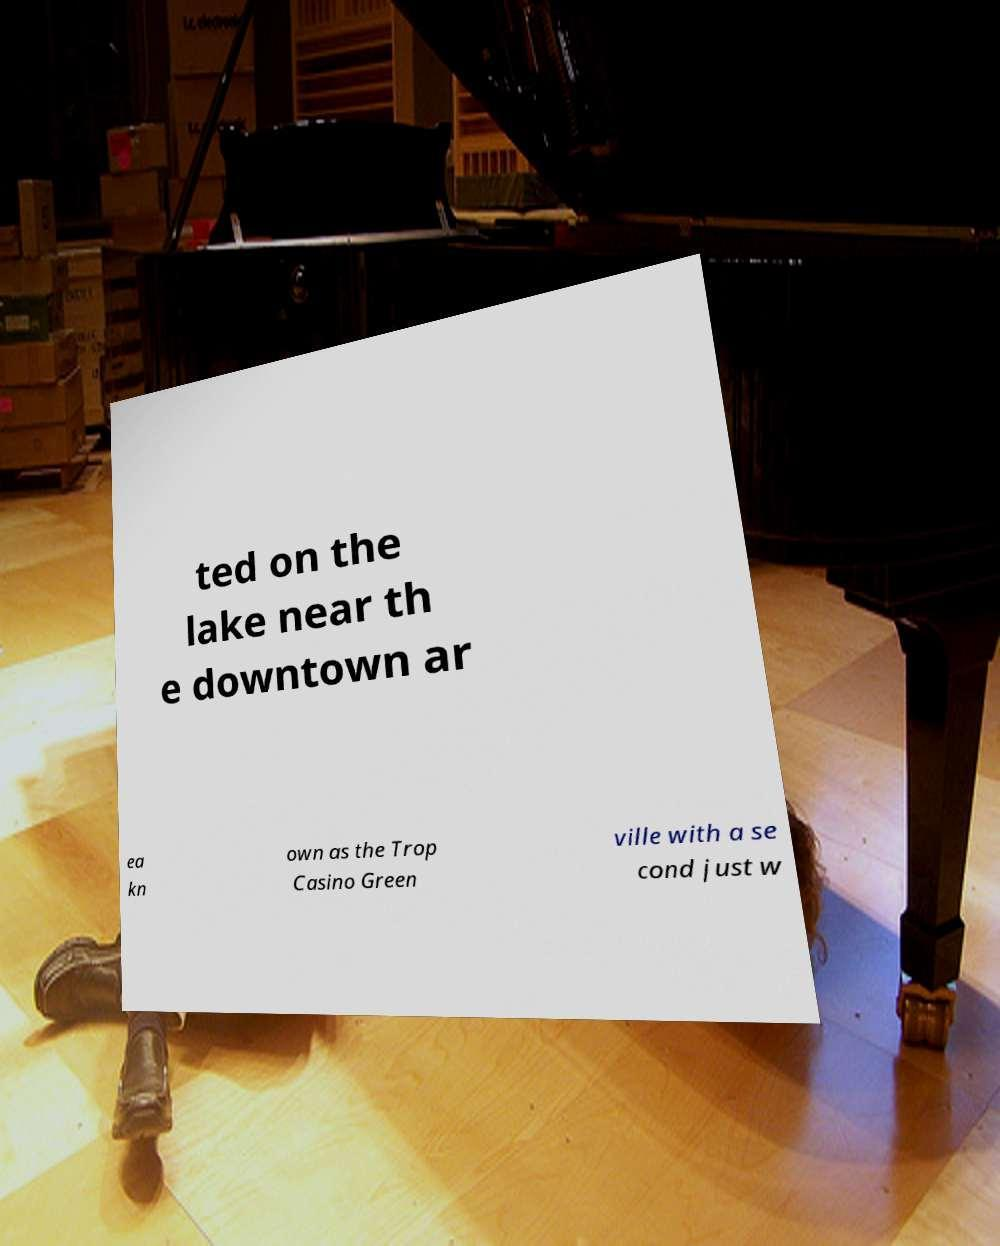I need the written content from this picture converted into text. Can you do that? ted on the lake near th e downtown ar ea kn own as the Trop Casino Green ville with a se cond just w 